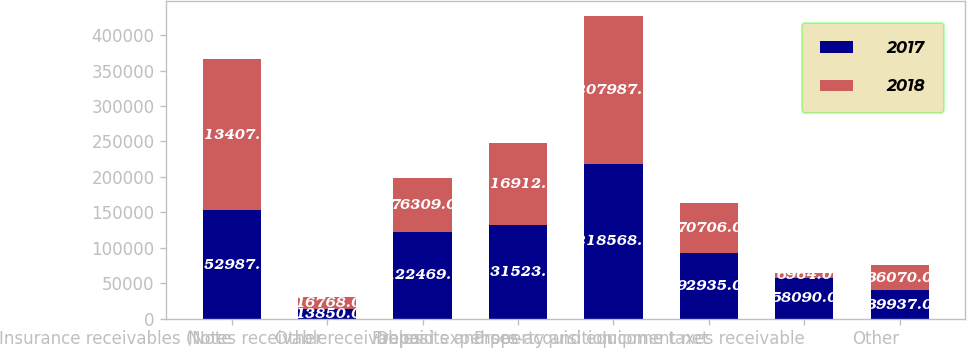Convert chart to OTSL. <chart><loc_0><loc_0><loc_500><loc_500><stacked_bar_chart><ecel><fcel>Insurance receivables (Note<fcel>Notes receivable<fcel>Other receivables<fcel>Prepaid expenses<fcel>Deposits and pre-acquisition<fcel>Property and equipment net<fcel>Income taxes receivable<fcel>Other<nl><fcel>2017<fcel>152987<fcel>13850<fcel>122469<fcel>131523<fcel>218568<fcel>92935<fcel>58090<fcel>39937<nl><fcel>2018<fcel>213407<fcel>16768<fcel>76309<fcel>116912<fcel>207987<fcel>70706<fcel>6964<fcel>36070<nl></chart> 